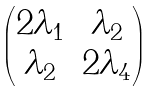Convert formula to latex. <formula><loc_0><loc_0><loc_500><loc_500>\begin{pmatrix} 2 \lambda _ { 1 } & \lambda _ { 2 } \\ \lambda _ { 2 } & 2 \lambda _ { 4 } \end{pmatrix}</formula> 